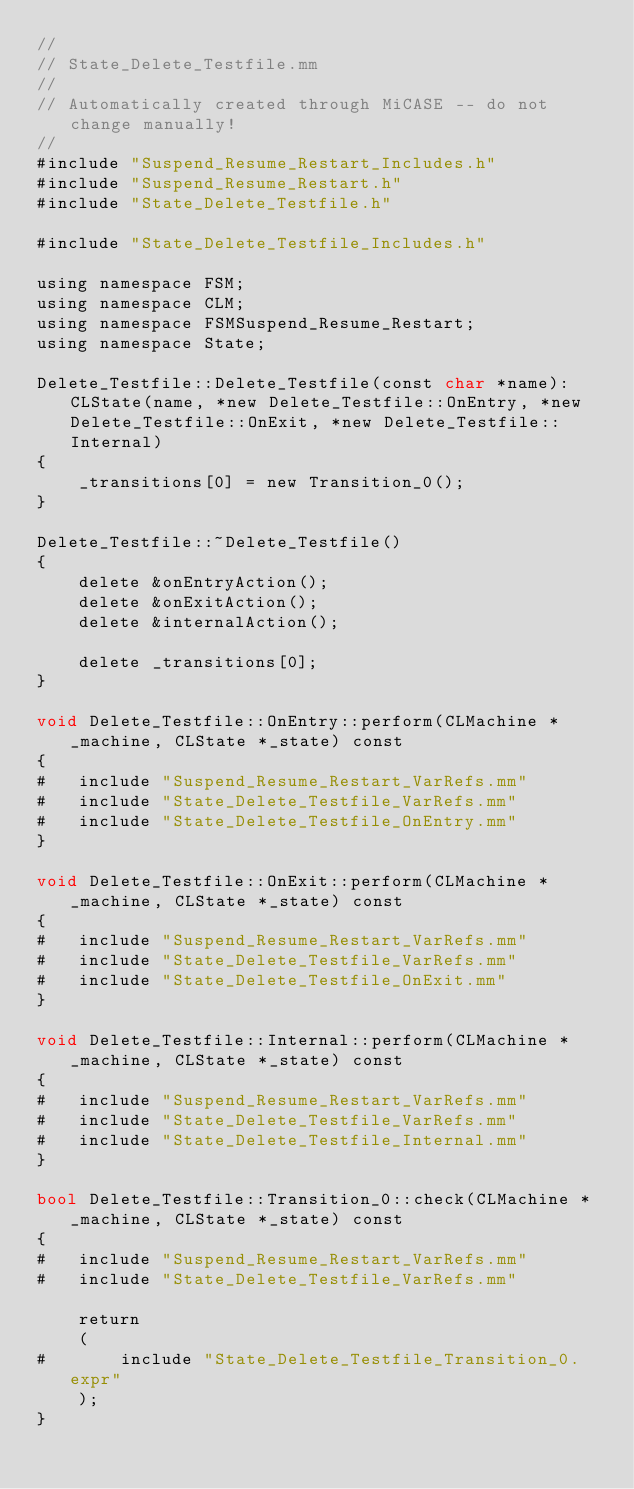Convert code to text. <code><loc_0><loc_0><loc_500><loc_500><_ObjectiveC_>//
// State_Delete_Testfile.mm
//
// Automatically created through MiCASE -- do not change manually!
//
#include "Suspend_Resume_Restart_Includes.h"
#include "Suspend_Resume_Restart.h"
#include "State_Delete_Testfile.h"

#include "State_Delete_Testfile_Includes.h"

using namespace FSM;
using namespace CLM;
using namespace FSMSuspend_Resume_Restart;
using namespace State;

Delete_Testfile::Delete_Testfile(const char *name): CLState(name, *new Delete_Testfile::OnEntry, *new Delete_Testfile::OnExit, *new Delete_Testfile::Internal)
{
	_transitions[0] = new Transition_0();
}

Delete_Testfile::~Delete_Testfile()
{
	delete &onEntryAction();
	delete &onExitAction();
	delete &internalAction();

	delete _transitions[0];
}

void Delete_Testfile::OnEntry::perform(CLMachine *_machine, CLState *_state) const
{
#	include "Suspend_Resume_Restart_VarRefs.mm"
#	include "State_Delete_Testfile_VarRefs.mm"
#	include "State_Delete_Testfile_OnEntry.mm"
}

void Delete_Testfile::OnExit::perform(CLMachine *_machine, CLState *_state) const
{
#	include "Suspend_Resume_Restart_VarRefs.mm"
#	include "State_Delete_Testfile_VarRefs.mm"
#	include "State_Delete_Testfile_OnExit.mm"
}

void Delete_Testfile::Internal::perform(CLMachine *_machine, CLState *_state) const
{
#	include "Suspend_Resume_Restart_VarRefs.mm"
#	include "State_Delete_Testfile_VarRefs.mm"
#	include "State_Delete_Testfile_Internal.mm"
}

bool Delete_Testfile::Transition_0::check(CLMachine *_machine, CLState *_state) const
{
#	include "Suspend_Resume_Restart_VarRefs.mm"
#	include "State_Delete_Testfile_VarRefs.mm"

	return
	(
#		include "State_Delete_Testfile_Transition_0.expr"
	);
}
</code> 